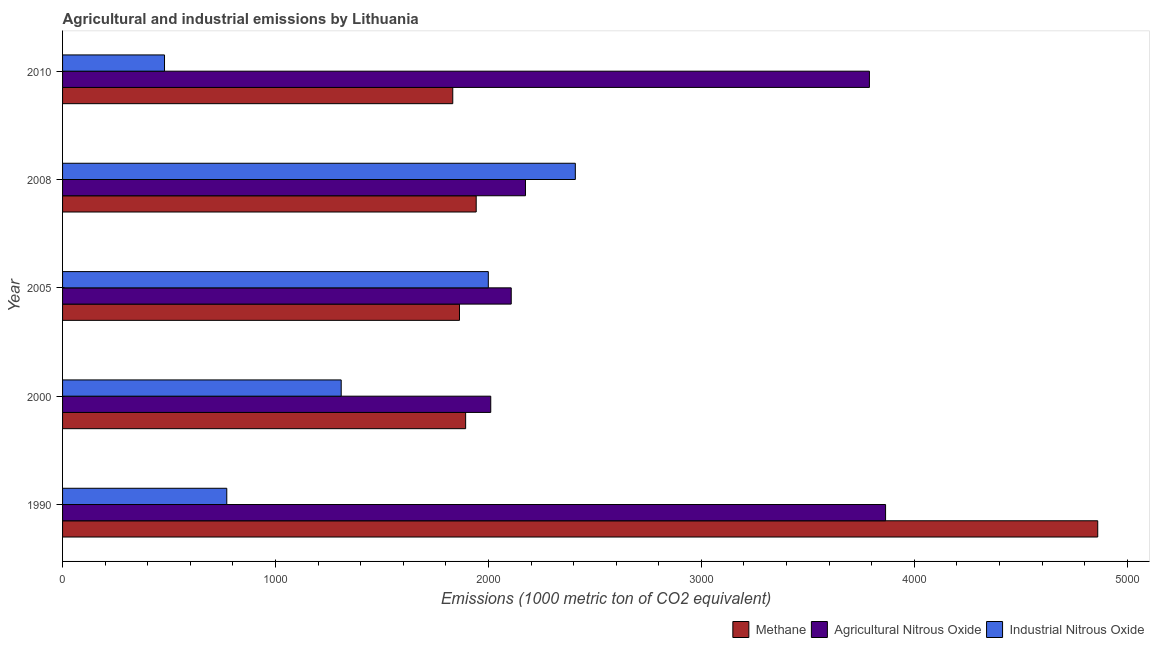How many different coloured bars are there?
Keep it short and to the point. 3. How many bars are there on the 3rd tick from the top?
Make the answer very short. 3. How many bars are there on the 4th tick from the bottom?
Offer a very short reply. 3. What is the amount of industrial nitrous oxide emissions in 2000?
Provide a succinct answer. 1308.5. Across all years, what is the maximum amount of agricultural nitrous oxide emissions?
Provide a succinct answer. 3865. Across all years, what is the minimum amount of industrial nitrous oxide emissions?
Give a very brief answer. 478.8. What is the total amount of agricultural nitrous oxide emissions in the graph?
Offer a very short reply. 1.39e+04. What is the difference between the amount of industrial nitrous oxide emissions in 1990 and that in 2000?
Offer a terse response. -537.3. What is the difference between the amount of methane emissions in 1990 and the amount of industrial nitrous oxide emissions in 2000?
Give a very brief answer. 3552.8. What is the average amount of industrial nitrous oxide emissions per year?
Make the answer very short. 1393.18. In the year 2010, what is the difference between the amount of agricultural nitrous oxide emissions and amount of industrial nitrous oxide emissions?
Keep it short and to the point. 3310.3. In how many years, is the amount of methane emissions greater than 800 metric ton?
Offer a very short reply. 5. Is the difference between the amount of methane emissions in 1990 and 2008 greater than the difference between the amount of agricultural nitrous oxide emissions in 1990 and 2008?
Your response must be concise. Yes. What is the difference between the highest and the second highest amount of agricultural nitrous oxide emissions?
Your answer should be compact. 75.9. What is the difference between the highest and the lowest amount of agricultural nitrous oxide emissions?
Provide a short and direct response. 1854.2. What does the 3rd bar from the top in 1990 represents?
Make the answer very short. Methane. What does the 2nd bar from the bottom in 1990 represents?
Your response must be concise. Agricultural Nitrous Oxide. How many years are there in the graph?
Keep it short and to the point. 5. What is the difference between two consecutive major ticks on the X-axis?
Offer a very short reply. 1000. Are the values on the major ticks of X-axis written in scientific E-notation?
Provide a short and direct response. No. Does the graph contain any zero values?
Ensure brevity in your answer.  No. Where does the legend appear in the graph?
Your answer should be very brief. Bottom right. How many legend labels are there?
Offer a terse response. 3. What is the title of the graph?
Make the answer very short. Agricultural and industrial emissions by Lithuania. Does "Slovak Republic" appear as one of the legend labels in the graph?
Your response must be concise. No. What is the label or title of the X-axis?
Make the answer very short. Emissions (1000 metric ton of CO2 equivalent). What is the label or title of the Y-axis?
Ensure brevity in your answer.  Year. What is the Emissions (1000 metric ton of CO2 equivalent) in Methane in 1990?
Offer a very short reply. 4861.3. What is the Emissions (1000 metric ton of CO2 equivalent) in Agricultural Nitrous Oxide in 1990?
Offer a terse response. 3865. What is the Emissions (1000 metric ton of CO2 equivalent) of Industrial Nitrous Oxide in 1990?
Ensure brevity in your answer.  771.2. What is the Emissions (1000 metric ton of CO2 equivalent) of Methane in 2000?
Your answer should be compact. 1892.9. What is the Emissions (1000 metric ton of CO2 equivalent) of Agricultural Nitrous Oxide in 2000?
Give a very brief answer. 2010.8. What is the Emissions (1000 metric ton of CO2 equivalent) in Industrial Nitrous Oxide in 2000?
Provide a succinct answer. 1308.5. What is the Emissions (1000 metric ton of CO2 equivalent) in Methane in 2005?
Provide a short and direct response. 1864. What is the Emissions (1000 metric ton of CO2 equivalent) of Agricultural Nitrous Oxide in 2005?
Give a very brief answer. 2107. What is the Emissions (1000 metric ton of CO2 equivalent) in Industrial Nitrous Oxide in 2005?
Provide a succinct answer. 1999.4. What is the Emissions (1000 metric ton of CO2 equivalent) in Methane in 2008?
Give a very brief answer. 1942.5. What is the Emissions (1000 metric ton of CO2 equivalent) of Agricultural Nitrous Oxide in 2008?
Provide a succinct answer. 2173.9. What is the Emissions (1000 metric ton of CO2 equivalent) in Industrial Nitrous Oxide in 2008?
Offer a terse response. 2408. What is the Emissions (1000 metric ton of CO2 equivalent) in Methane in 2010?
Provide a succinct answer. 1832.4. What is the Emissions (1000 metric ton of CO2 equivalent) of Agricultural Nitrous Oxide in 2010?
Offer a very short reply. 3789.1. What is the Emissions (1000 metric ton of CO2 equivalent) in Industrial Nitrous Oxide in 2010?
Your response must be concise. 478.8. Across all years, what is the maximum Emissions (1000 metric ton of CO2 equivalent) in Methane?
Give a very brief answer. 4861.3. Across all years, what is the maximum Emissions (1000 metric ton of CO2 equivalent) in Agricultural Nitrous Oxide?
Offer a terse response. 3865. Across all years, what is the maximum Emissions (1000 metric ton of CO2 equivalent) of Industrial Nitrous Oxide?
Make the answer very short. 2408. Across all years, what is the minimum Emissions (1000 metric ton of CO2 equivalent) of Methane?
Offer a very short reply. 1832.4. Across all years, what is the minimum Emissions (1000 metric ton of CO2 equivalent) in Agricultural Nitrous Oxide?
Make the answer very short. 2010.8. Across all years, what is the minimum Emissions (1000 metric ton of CO2 equivalent) of Industrial Nitrous Oxide?
Make the answer very short. 478.8. What is the total Emissions (1000 metric ton of CO2 equivalent) in Methane in the graph?
Give a very brief answer. 1.24e+04. What is the total Emissions (1000 metric ton of CO2 equivalent) of Agricultural Nitrous Oxide in the graph?
Provide a succinct answer. 1.39e+04. What is the total Emissions (1000 metric ton of CO2 equivalent) of Industrial Nitrous Oxide in the graph?
Your answer should be very brief. 6965.9. What is the difference between the Emissions (1000 metric ton of CO2 equivalent) in Methane in 1990 and that in 2000?
Ensure brevity in your answer.  2968.4. What is the difference between the Emissions (1000 metric ton of CO2 equivalent) in Agricultural Nitrous Oxide in 1990 and that in 2000?
Make the answer very short. 1854.2. What is the difference between the Emissions (1000 metric ton of CO2 equivalent) in Industrial Nitrous Oxide in 1990 and that in 2000?
Make the answer very short. -537.3. What is the difference between the Emissions (1000 metric ton of CO2 equivalent) in Methane in 1990 and that in 2005?
Your response must be concise. 2997.3. What is the difference between the Emissions (1000 metric ton of CO2 equivalent) in Agricultural Nitrous Oxide in 1990 and that in 2005?
Give a very brief answer. 1758. What is the difference between the Emissions (1000 metric ton of CO2 equivalent) in Industrial Nitrous Oxide in 1990 and that in 2005?
Your answer should be very brief. -1228.2. What is the difference between the Emissions (1000 metric ton of CO2 equivalent) of Methane in 1990 and that in 2008?
Keep it short and to the point. 2918.8. What is the difference between the Emissions (1000 metric ton of CO2 equivalent) of Agricultural Nitrous Oxide in 1990 and that in 2008?
Your answer should be compact. 1691.1. What is the difference between the Emissions (1000 metric ton of CO2 equivalent) in Industrial Nitrous Oxide in 1990 and that in 2008?
Keep it short and to the point. -1636.8. What is the difference between the Emissions (1000 metric ton of CO2 equivalent) of Methane in 1990 and that in 2010?
Make the answer very short. 3028.9. What is the difference between the Emissions (1000 metric ton of CO2 equivalent) of Agricultural Nitrous Oxide in 1990 and that in 2010?
Make the answer very short. 75.9. What is the difference between the Emissions (1000 metric ton of CO2 equivalent) in Industrial Nitrous Oxide in 1990 and that in 2010?
Make the answer very short. 292.4. What is the difference between the Emissions (1000 metric ton of CO2 equivalent) of Methane in 2000 and that in 2005?
Offer a terse response. 28.9. What is the difference between the Emissions (1000 metric ton of CO2 equivalent) of Agricultural Nitrous Oxide in 2000 and that in 2005?
Your answer should be very brief. -96.2. What is the difference between the Emissions (1000 metric ton of CO2 equivalent) in Industrial Nitrous Oxide in 2000 and that in 2005?
Keep it short and to the point. -690.9. What is the difference between the Emissions (1000 metric ton of CO2 equivalent) in Methane in 2000 and that in 2008?
Give a very brief answer. -49.6. What is the difference between the Emissions (1000 metric ton of CO2 equivalent) of Agricultural Nitrous Oxide in 2000 and that in 2008?
Keep it short and to the point. -163.1. What is the difference between the Emissions (1000 metric ton of CO2 equivalent) in Industrial Nitrous Oxide in 2000 and that in 2008?
Give a very brief answer. -1099.5. What is the difference between the Emissions (1000 metric ton of CO2 equivalent) in Methane in 2000 and that in 2010?
Your answer should be compact. 60.5. What is the difference between the Emissions (1000 metric ton of CO2 equivalent) in Agricultural Nitrous Oxide in 2000 and that in 2010?
Your answer should be compact. -1778.3. What is the difference between the Emissions (1000 metric ton of CO2 equivalent) of Industrial Nitrous Oxide in 2000 and that in 2010?
Your answer should be very brief. 829.7. What is the difference between the Emissions (1000 metric ton of CO2 equivalent) of Methane in 2005 and that in 2008?
Give a very brief answer. -78.5. What is the difference between the Emissions (1000 metric ton of CO2 equivalent) of Agricultural Nitrous Oxide in 2005 and that in 2008?
Offer a terse response. -66.9. What is the difference between the Emissions (1000 metric ton of CO2 equivalent) of Industrial Nitrous Oxide in 2005 and that in 2008?
Provide a succinct answer. -408.6. What is the difference between the Emissions (1000 metric ton of CO2 equivalent) in Methane in 2005 and that in 2010?
Your answer should be compact. 31.6. What is the difference between the Emissions (1000 metric ton of CO2 equivalent) of Agricultural Nitrous Oxide in 2005 and that in 2010?
Keep it short and to the point. -1682.1. What is the difference between the Emissions (1000 metric ton of CO2 equivalent) of Industrial Nitrous Oxide in 2005 and that in 2010?
Your response must be concise. 1520.6. What is the difference between the Emissions (1000 metric ton of CO2 equivalent) of Methane in 2008 and that in 2010?
Keep it short and to the point. 110.1. What is the difference between the Emissions (1000 metric ton of CO2 equivalent) of Agricultural Nitrous Oxide in 2008 and that in 2010?
Ensure brevity in your answer.  -1615.2. What is the difference between the Emissions (1000 metric ton of CO2 equivalent) of Industrial Nitrous Oxide in 2008 and that in 2010?
Provide a succinct answer. 1929.2. What is the difference between the Emissions (1000 metric ton of CO2 equivalent) in Methane in 1990 and the Emissions (1000 metric ton of CO2 equivalent) in Agricultural Nitrous Oxide in 2000?
Provide a succinct answer. 2850.5. What is the difference between the Emissions (1000 metric ton of CO2 equivalent) in Methane in 1990 and the Emissions (1000 metric ton of CO2 equivalent) in Industrial Nitrous Oxide in 2000?
Keep it short and to the point. 3552.8. What is the difference between the Emissions (1000 metric ton of CO2 equivalent) in Agricultural Nitrous Oxide in 1990 and the Emissions (1000 metric ton of CO2 equivalent) in Industrial Nitrous Oxide in 2000?
Your response must be concise. 2556.5. What is the difference between the Emissions (1000 metric ton of CO2 equivalent) in Methane in 1990 and the Emissions (1000 metric ton of CO2 equivalent) in Agricultural Nitrous Oxide in 2005?
Your response must be concise. 2754.3. What is the difference between the Emissions (1000 metric ton of CO2 equivalent) of Methane in 1990 and the Emissions (1000 metric ton of CO2 equivalent) of Industrial Nitrous Oxide in 2005?
Your answer should be very brief. 2861.9. What is the difference between the Emissions (1000 metric ton of CO2 equivalent) in Agricultural Nitrous Oxide in 1990 and the Emissions (1000 metric ton of CO2 equivalent) in Industrial Nitrous Oxide in 2005?
Your answer should be compact. 1865.6. What is the difference between the Emissions (1000 metric ton of CO2 equivalent) of Methane in 1990 and the Emissions (1000 metric ton of CO2 equivalent) of Agricultural Nitrous Oxide in 2008?
Your answer should be very brief. 2687.4. What is the difference between the Emissions (1000 metric ton of CO2 equivalent) of Methane in 1990 and the Emissions (1000 metric ton of CO2 equivalent) of Industrial Nitrous Oxide in 2008?
Your answer should be compact. 2453.3. What is the difference between the Emissions (1000 metric ton of CO2 equivalent) of Agricultural Nitrous Oxide in 1990 and the Emissions (1000 metric ton of CO2 equivalent) of Industrial Nitrous Oxide in 2008?
Your response must be concise. 1457. What is the difference between the Emissions (1000 metric ton of CO2 equivalent) of Methane in 1990 and the Emissions (1000 metric ton of CO2 equivalent) of Agricultural Nitrous Oxide in 2010?
Offer a very short reply. 1072.2. What is the difference between the Emissions (1000 metric ton of CO2 equivalent) of Methane in 1990 and the Emissions (1000 metric ton of CO2 equivalent) of Industrial Nitrous Oxide in 2010?
Provide a short and direct response. 4382.5. What is the difference between the Emissions (1000 metric ton of CO2 equivalent) of Agricultural Nitrous Oxide in 1990 and the Emissions (1000 metric ton of CO2 equivalent) of Industrial Nitrous Oxide in 2010?
Offer a very short reply. 3386.2. What is the difference between the Emissions (1000 metric ton of CO2 equivalent) of Methane in 2000 and the Emissions (1000 metric ton of CO2 equivalent) of Agricultural Nitrous Oxide in 2005?
Provide a succinct answer. -214.1. What is the difference between the Emissions (1000 metric ton of CO2 equivalent) in Methane in 2000 and the Emissions (1000 metric ton of CO2 equivalent) in Industrial Nitrous Oxide in 2005?
Your answer should be compact. -106.5. What is the difference between the Emissions (1000 metric ton of CO2 equivalent) in Methane in 2000 and the Emissions (1000 metric ton of CO2 equivalent) in Agricultural Nitrous Oxide in 2008?
Offer a terse response. -281. What is the difference between the Emissions (1000 metric ton of CO2 equivalent) in Methane in 2000 and the Emissions (1000 metric ton of CO2 equivalent) in Industrial Nitrous Oxide in 2008?
Give a very brief answer. -515.1. What is the difference between the Emissions (1000 metric ton of CO2 equivalent) in Agricultural Nitrous Oxide in 2000 and the Emissions (1000 metric ton of CO2 equivalent) in Industrial Nitrous Oxide in 2008?
Give a very brief answer. -397.2. What is the difference between the Emissions (1000 metric ton of CO2 equivalent) in Methane in 2000 and the Emissions (1000 metric ton of CO2 equivalent) in Agricultural Nitrous Oxide in 2010?
Offer a very short reply. -1896.2. What is the difference between the Emissions (1000 metric ton of CO2 equivalent) of Methane in 2000 and the Emissions (1000 metric ton of CO2 equivalent) of Industrial Nitrous Oxide in 2010?
Provide a succinct answer. 1414.1. What is the difference between the Emissions (1000 metric ton of CO2 equivalent) of Agricultural Nitrous Oxide in 2000 and the Emissions (1000 metric ton of CO2 equivalent) of Industrial Nitrous Oxide in 2010?
Keep it short and to the point. 1532. What is the difference between the Emissions (1000 metric ton of CO2 equivalent) in Methane in 2005 and the Emissions (1000 metric ton of CO2 equivalent) in Agricultural Nitrous Oxide in 2008?
Keep it short and to the point. -309.9. What is the difference between the Emissions (1000 metric ton of CO2 equivalent) of Methane in 2005 and the Emissions (1000 metric ton of CO2 equivalent) of Industrial Nitrous Oxide in 2008?
Provide a succinct answer. -544. What is the difference between the Emissions (1000 metric ton of CO2 equivalent) of Agricultural Nitrous Oxide in 2005 and the Emissions (1000 metric ton of CO2 equivalent) of Industrial Nitrous Oxide in 2008?
Offer a very short reply. -301. What is the difference between the Emissions (1000 metric ton of CO2 equivalent) of Methane in 2005 and the Emissions (1000 metric ton of CO2 equivalent) of Agricultural Nitrous Oxide in 2010?
Provide a short and direct response. -1925.1. What is the difference between the Emissions (1000 metric ton of CO2 equivalent) of Methane in 2005 and the Emissions (1000 metric ton of CO2 equivalent) of Industrial Nitrous Oxide in 2010?
Provide a short and direct response. 1385.2. What is the difference between the Emissions (1000 metric ton of CO2 equivalent) in Agricultural Nitrous Oxide in 2005 and the Emissions (1000 metric ton of CO2 equivalent) in Industrial Nitrous Oxide in 2010?
Offer a very short reply. 1628.2. What is the difference between the Emissions (1000 metric ton of CO2 equivalent) of Methane in 2008 and the Emissions (1000 metric ton of CO2 equivalent) of Agricultural Nitrous Oxide in 2010?
Provide a short and direct response. -1846.6. What is the difference between the Emissions (1000 metric ton of CO2 equivalent) of Methane in 2008 and the Emissions (1000 metric ton of CO2 equivalent) of Industrial Nitrous Oxide in 2010?
Keep it short and to the point. 1463.7. What is the difference between the Emissions (1000 metric ton of CO2 equivalent) of Agricultural Nitrous Oxide in 2008 and the Emissions (1000 metric ton of CO2 equivalent) of Industrial Nitrous Oxide in 2010?
Keep it short and to the point. 1695.1. What is the average Emissions (1000 metric ton of CO2 equivalent) in Methane per year?
Ensure brevity in your answer.  2478.62. What is the average Emissions (1000 metric ton of CO2 equivalent) in Agricultural Nitrous Oxide per year?
Your answer should be very brief. 2789.16. What is the average Emissions (1000 metric ton of CO2 equivalent) in Industrial Nitrous Oxide per year?
Make the answer very short. 1393.18. In the year 1990, what is the difference between the Emissions (1000 metric ton of CO2 equivalent) of Methane and Emissions (1000 metric ton of CO2 equivalent) of Agricultural Nitrous Oxide?
Keep it short and to the point. 996.3. In the year 1990, what is the difference between the Emissions (1000 metric ton of CO2 equivalent) of Methane and Emissions (1000 metric ton of CO2 equivalent) of Industrial Nitrous Oxide?
Your answer should be very brief. 4090.1. In the year 1990, what is the difference between the Emissions (1000 metric ton of CO2 equivalent) in Agricultural Nitrous Oxide and Emissions (1000 metric ton of CO2 equivalent) in Industrial Nitrous Oxide?
Provide a succinct answer. 3093.8. In the year 2000, what is the difference between the Emissions (1000 metric ton of CO2 equivalent) of Methane and Emissions (1000 metric ton of CO2 equivalent) of Agricultural Nitrous Oxide?
Ensure brevity in your answer.  -117.9. In the year 2000, what is the difference between the Emissions (1000 metric ton of CO2 equivalent) of Methane and Emissions (1000 metric ton of CO2 equivalent) of Industrial Nitrous Oxide?
Keep it short and to the point. 584.4. In the year 2000, what is the difference between the Emissions (1000 metric ton of CO2 equivalent) of Agricultural Nitrous Oxide and Emissions (1000 metric ton of CO2 equivalent) of Industrial Nitrous Oxide?
Ensure brevity in your answer.  702.3. In the year 2005, what is the difference between the Emissions (1000 metric ton of CO2 equivalent) of Methane and Emissions (1000 metric ton of CO2 equivalent) of Agricultural Nitrous Oxide?
Your answer should be compact. -243. In the year 2005, what is the difference between the Emissions (1000 metric ton of CO2 equivalent) in Methane and Emissions (1000 metric ton of CO2 equivalent) in Industrial Nitrous Oxide?
Your answer should be compact. -135.4. In the year 2005, what is the difference between the Emissions (1000 metric ton of CO2 equivalent) of Agricultural Nitrous Oxide and Emissions (1000 metric ton of CO2 equivalent) of Industrial Nitrous Oxide?
Your answer should be compact. 107.6. In the year 2008, what is the difference between the Emissions (1000 metric ton of CO2 equivalent) in Methane and Emissions (1000 metric ton of CO2 equivalent) in Agricultural Nitrous Oxide?
Offer a terse response. -231.4. In the year 2008, what is the difference between the Emissions (1000 metric ton of CO2 equivalent) in Methane and Emissions (1000 metric ton of CO2 equivalent) in Industrial Nitrous Oxide?
Keep it short and to the point. -465.5. In the year 2008, what is the difference between the Emissions (1000 metric ton of CO2 equivalent) in Agricultural Nitrous Oxide and Emissions (1000 metric ton of CO2 equivalent) in Industrial Nitrous Oxide?
Your answer should be very brief. -234.1. In the year 2010, what is the difference between the Emissions (1000 metric ton of CO2 equivalent) of Methane and Emissions (1000 metric ton of CO2 equivalent) of Agricultural Nitrous Oxide?
Provide a succinct answer. -1956.7. In the year 2010, what is the difference between the Emissions (1000 metric ton of CO2 equivalent) in Methane and Emissions (1000 metric ton of CO2 equivalent) in Industrial Nitrous Oxide?
Give a very brief answer. 1353.6. In the year 2010, what is the difference between the Emissions (1000 metric ton of CO2 equivalent) of Agricultural Nitrous Oxide and Emissions (1000 metric ton of CO2 equivalent) of Industrial Nitrous Oxide?
Make the answer very short. 3310.3. What is the ratio of the Emissions (1000 metric ton of CO2 equivalent) in Methane in 1990 to that in 2000?
Provide a succinct answer. 2.57. What is the ratio of the Emissions (1000 metric ton of CO2 equivalent) in Agricultural Nitrous Oxide in 1990 to that in 2000?
Keep it short and to the point. 1.92. What is the ratio of the Emissions (1000 metric ton of CO2 equivalent) in Industrial Nitrous Oxide in 1990 to that in 2000?
Your answer should be compact. 0.59. What is the ratio of the Emissions (1000 metric ton of CO2 equivalent) of Methane in 1990 to that in 2005?
Provide a short and direct response. 2.61. What is the ratio of the Emissions (1000 metric ton of CO2 equivalent) of Agricultural Nitrous Oxide in 1990 to that in 2005?
Ensure brevity in your answer.  1.83. What is the ratio of the Emissions (1000 metric ton of CO2 equivalent) in Industrial Nitrous Oxide in 1990 to that in 2005?
Keep it short and to the point. 0.39. What is the ratio of the Emissions (1000 metric ton of CO2 equivalent) of Methane in 1990 to that in 2008?
Ensure brevity in your answer.  2.5. What is the ratio of the Emissions (1000 metric ton of CO2 equivalent) in Agricultural Nitrous Oxide in 1990 to that in 2008?
Give a very brief answer. 1.78. What is the ratio of the Emissions (1000 metric ton of CO2 equivalent) in Industrial Nitrous Oxide in 1990 to that in 2008?
Give a very brief answer. 0.32. What is the ratio of the Emissions (1000 metric ton of CO2 equivalent) of Methane in 1990 to that in 2010?
Your answer should be compact. 2.65. What is the ratio of the Emissions (1000 metric ton of CO2 equivalent) in Agricultural Nitrous Oxide in 1990 to that in 2010?
Ensure brevity in your answer.  1.02. What is the ratio of the Emissions (1000 metric ton of CO2 equivalent) in Industrial Nitrous Oxide in 1990 to that in 2010?
Your answer should be very brief. 1.61. What is the ratio of the Emissions (1000 metric ton of CO2 equivalent) of Methane in 2000 to that in 2005?
Ensure brevity in your answer.  1.02. What is the ratio of the Emissions (1000 metric ton of CO2 equivalent) of Agricultural Nitrous Oxide in 2000 to that in 2005?
Your response must be concise. 0.95. What is the ratio of the Emissions (1000 metric ton of CO2 equivalent) in Industrial Nitrous Oxide in 2000 to that in 2005?
Your answer should be very brief. 0.65. What is the ratio of the Emissions (1000 metric ton of CO2 equivalent) of Methane in 2000 to that in 2008?
Your answer should be compact. 0.97. What is the ratio of the Emissions (1000 metric ton of CO2 equivalent) in Agricultural Nitrous Oxide in 2000 to that in 2008?
Your response must be concise. 0.93. What is the ratio of the Emissions (1000 metric ton of CO2 equivalent) in Industrial Nitrous Oxide in 2000 to that in 2008?
Keep it short and to the point. 0.54. What is the ratio of the Emissions (1000 metric ton of CO2 equivalent) in Methane in 2000 to that in 2010?
Give a very brief answer. 1.03. What is the ratio of the Emissions (1000 metric ton of CO2 equivalent) of Agricultural Nitrous Oxide in 2000 to that in 2010?
Your response must be concise. 0.53. What is the ratio of the Emissions (1000 metric ton of CO2 equivalent) of Industrial Nitrous Oxide in 2000 to that in 2010?
Ensure brevity in your answer.  2.73. What is the ratio of the Emissions (1000 metric ton of CO2 equivalent) in Methane in 2005 to that in 2008?
Give a very brief answer. 0.96. What is the ratio of the Emissions (1000 metric ton of CO2 equivalent) in Agricultural Nitrous Oxide in 2005 to that in 2008?
Keep it short and to the point. 0.97. What is the ratio of the Emissions (1000 metric ton of CO2 equivalent) in Industrial Nitrous Oxide in 2005 to that in 2008?
Provide a succinct answer. 0.83. What is the ratio of the Emissions (1000 metric ton of CO2 equivalent) in Methane in 2005 to that in 2010?
Your response must be concise. 1.02. What is the ratio of the Emissions (1000 metric ton of CO2 equivalent) in Agricultural Nitrous Oxide in 2005 to that in 2010?
Keep it short and to the point. 0.56. What is the ratio of the Emissions (1000 metric ton of CO2 equivalent) of Industrial Nitrous Oxide in 2005 to that in 2010?
Your answer should be compact. 4.18. What is the ratio of the Emissions (1000 metric ton of CO2 equivalent) of Methane in 2008 to that in 2010?
Provide a short and direct response. 1.06. What is the ratio of the Emissions (1000 metric ton of CO2 equivalent) of Agricultural Nitrous Oxide in 2008 to that in 2010?
Your answer should be compact. 0.57. What is the ratio of the Emissions (1000 metric ton of CO2 equivalent) of Industrial Nitrous Oxide in 2008 to that in 2010?
Give a very brief answer. 5.03. What is the difference between the highest and the second highest Emissions (1000 metric ton of CO2 equivalent) in Methane?
Your answer should be very brief. 2918.8. What is the difference between the highest and the second highest Emissions (1000 metric ton of CO2 equivalent) in Agricultural Nitrous Oxide?
Provide a succinct answer. 75.9. What is the difference between the highest and the second highest Emissions (1000 metric ton of CO2 equivalent) of Industrial Nitrous Oxide?
Keep it short and to the point. 408.6. What is the difference between the highest and the lowest Emissions (1000 metric ton of CO2 equivalent) in Methane?
Offer a terse response. 3028.9. What is the difference between the highest and the lowest Emissions (1000 metric ton of CO2 equivalent) of Agricultural Nitrous Oxide?
Give a very brief answer. 1854.2. What is the difference between the highest and the lowest Emissions (1000 metric ton of CO2 equivalent) in Industrial Nitrous Oxide?
Give a very brief answer. 1929.2. 